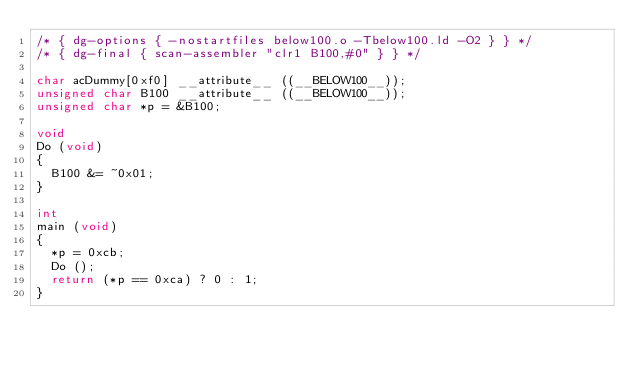Convert code to text. <code><loc_0><loc_0><loc_500><loc_500><_C_>/* { dg-options { -nostartfiles below100.o -Tbelow100.ld -O2 } } */
/* { dg-final { scan-assembler "clr1 B100,#0" } } */

char acDummy[0xf0] __attribute__ ((__BELOW100__));
unsigned char B100 __attribute__ ((__BELOW100__));
unsigned char *p = &B100;

void
Do (void)
{
  B100 &= ~0x01;
}

int
main (void)
{
  *p = 0xcb;
  Do ();
  return (*p == 0xca) ? 0 : 1;
}
</code> 